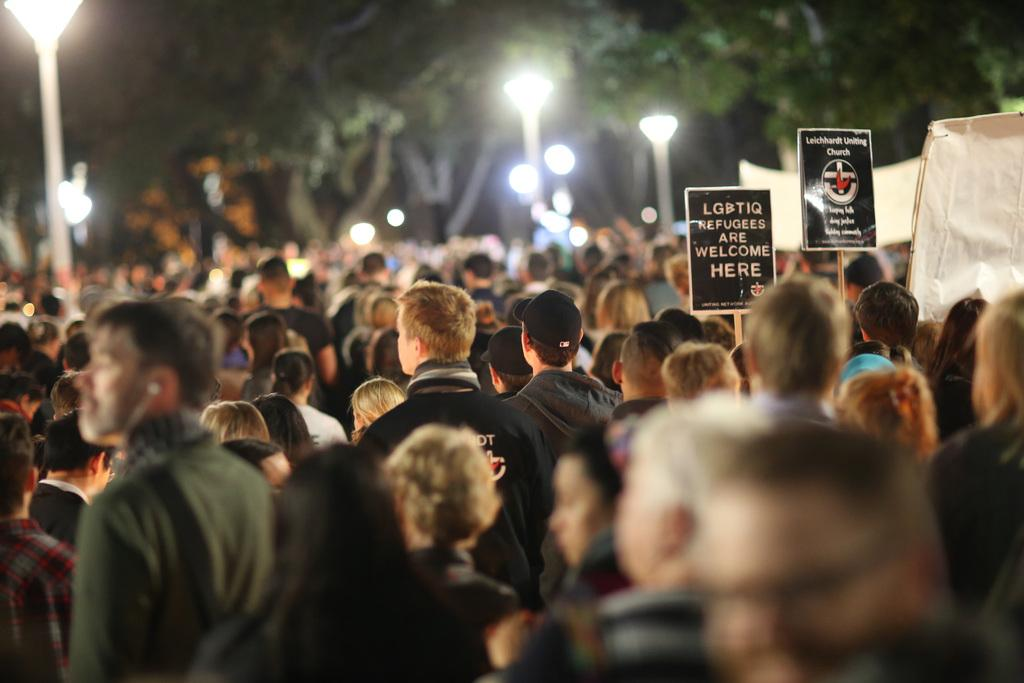What is located at the bottom of the image? There is a crowd at the bottom of the image. What can be seen in the background of the image? There are lights and trees visible in the background. Where are the posters located in the image? The posters are on the right side of the image. How many minutes does it take for the geese to fly across the image? There are no geese present in the image, so it is not possible to determine how long it would take for them to fly across. 